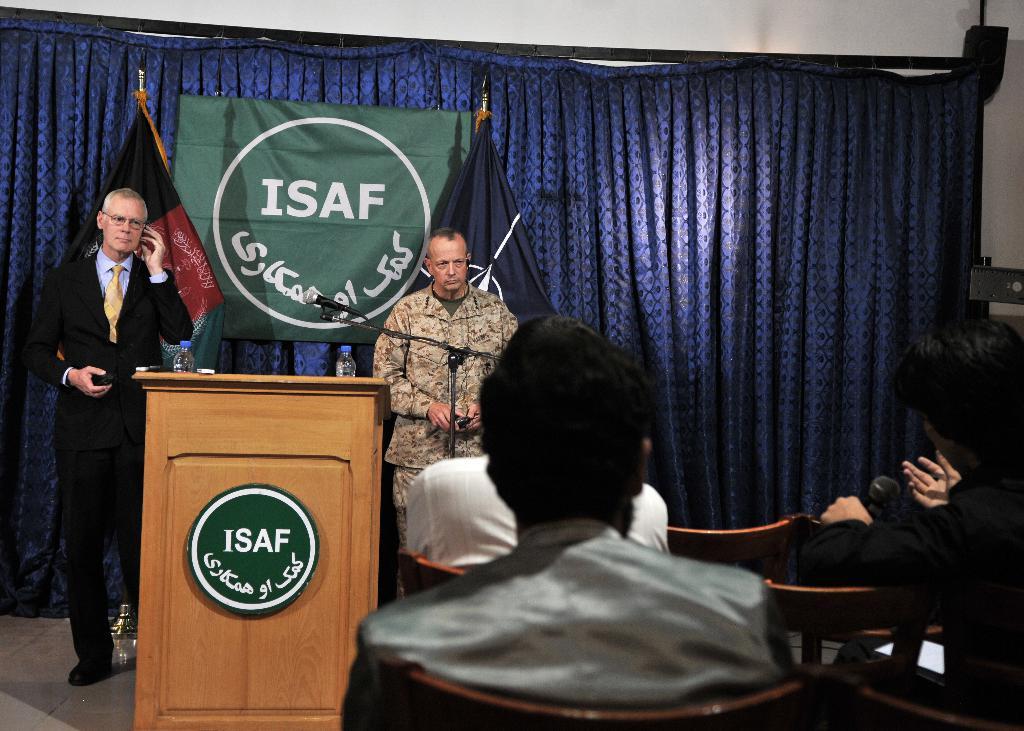What is the english letters on the green flag?
Provide a succinct answer. Isaf. 